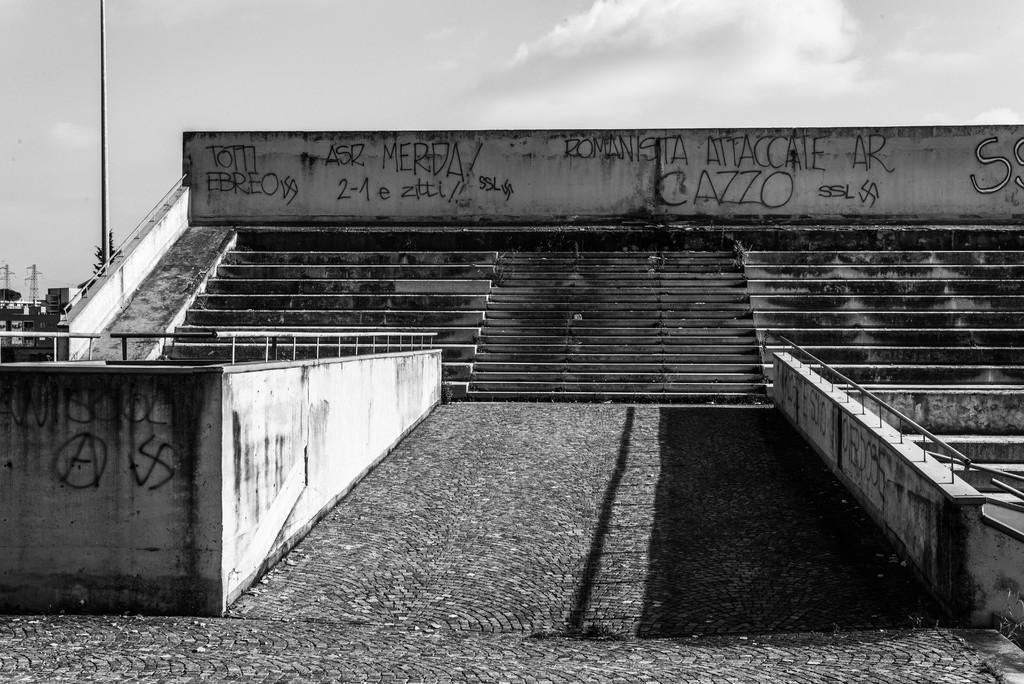Could you give a brief overview of what you see in this image? This is a black and white pic. We can see steps, texts written on the walls and railings. In the background we can see a pole, tree, towers, objects and clouds in the sky. 